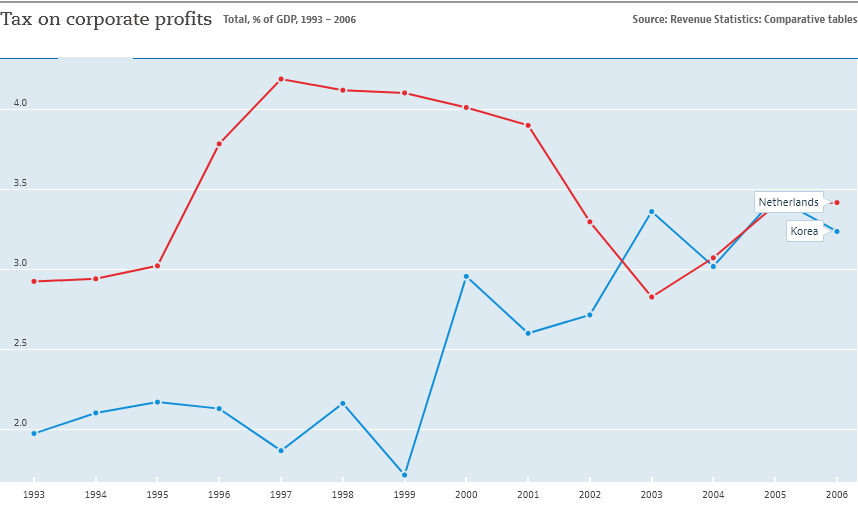Draw attention to some important aspects in this diagram. The country represented by the blue color line is Korea. In the year 1997, corporate profits in the Netherlands reached their highest point to date. 